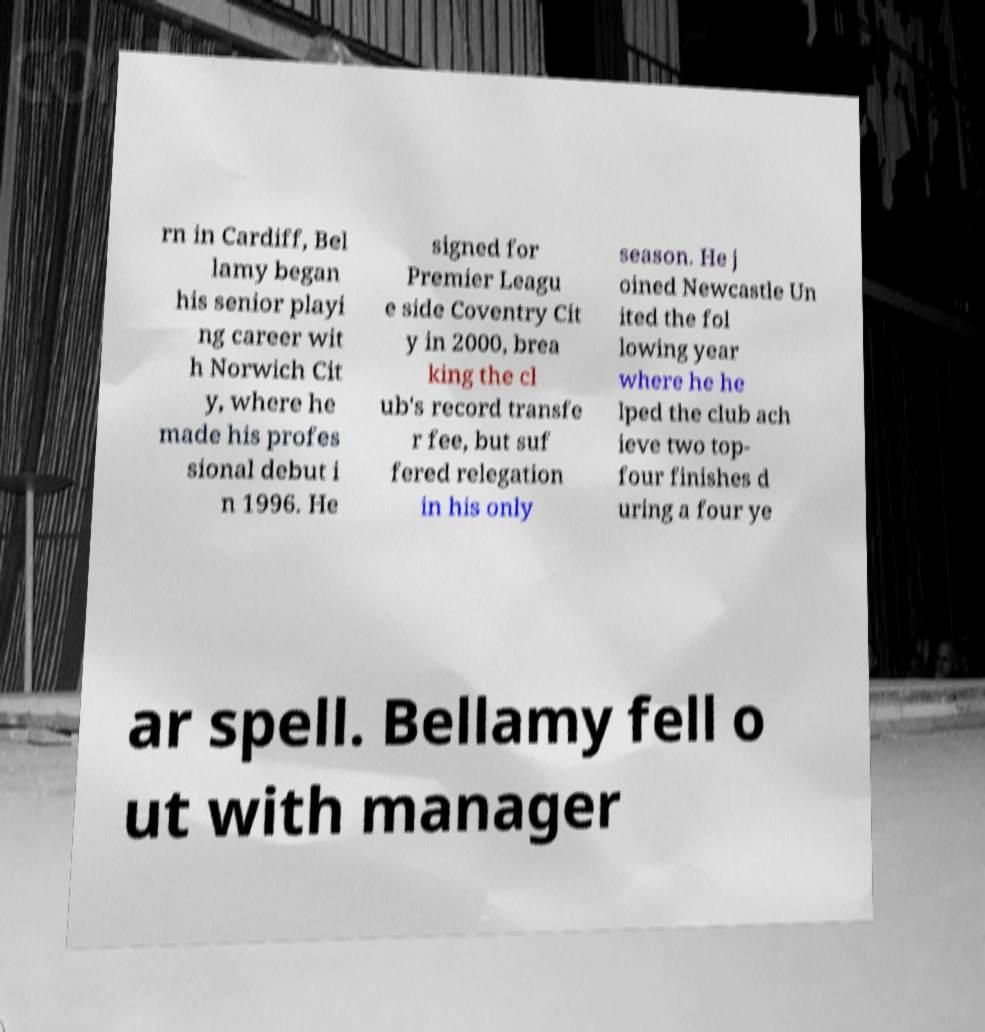Can you read and provide the text displayed in the image?This photo seems to have some interesting text. Can you extract and type it out for me? rn in Cardiff, Bel lamy began his senior playi ng career wit h Norwich Cit y, where he made his profes sional debut i n 1996. He signed for Premier Leagu e side Coventry Cit y in 2000, brea king the cl ub's record transfe r fee, but suf fered relegation in his only season. He j oined Newcastle Un ited the fol lowing year where he he lped the club ach ieve two top- four finishes d uring a four ye ar spell. Bellamy fell o ut with manager 